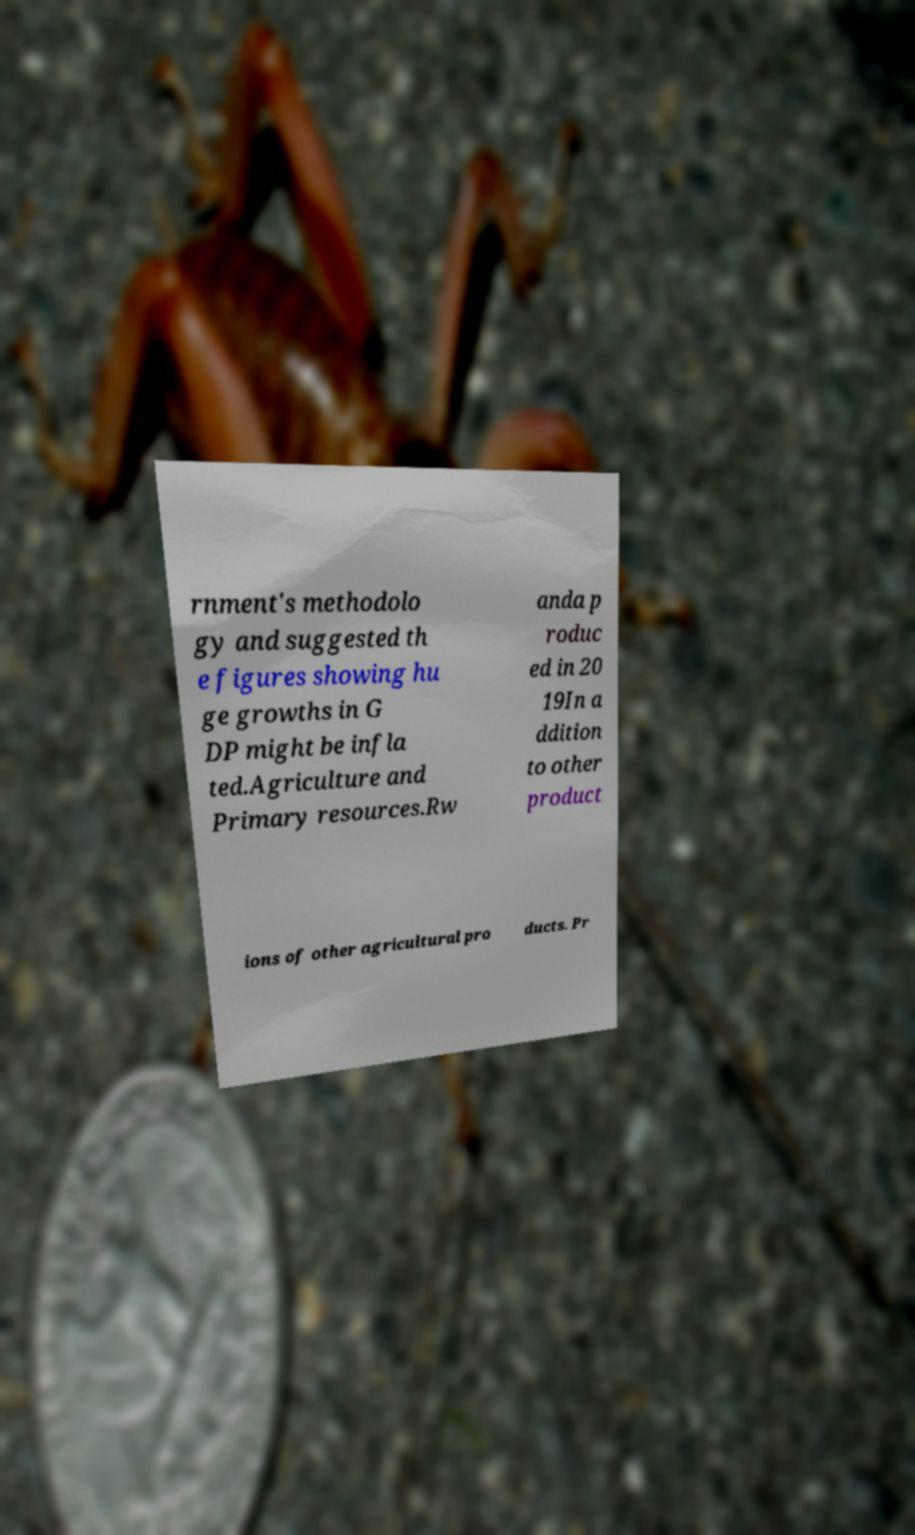Please read and relay the text visible in this image. What does it say? rnment's methodolo gy and suggested th e figures showing hu ge growths in G DP might be infla ted.Agriculture and Primary resources.Rw anda p roduc ed in 20 19In a ddition to other product ions of other agricultural pro ducts. Pr 